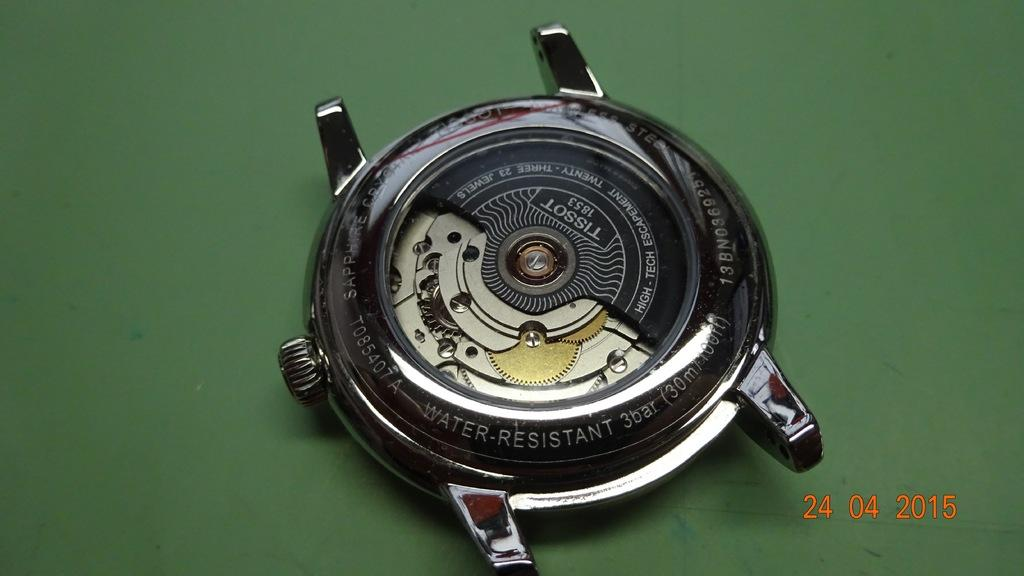<image>
Summarize the visual content of the image. A water resistant watch face is laying on a green table. 